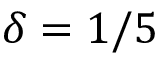<formula> <loc_0><loc_0><loc_500><loc_500>\delta = 1 / 5</formula> 